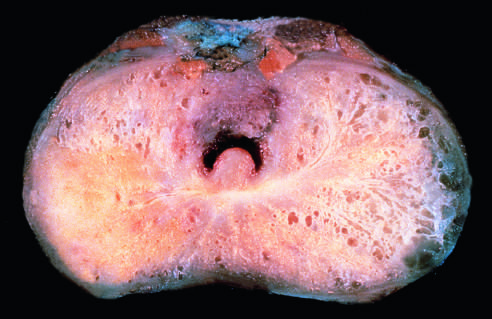where is carcinomatous tissue seen?
Answer the question using a single word or phrase. On the posterior aspect 